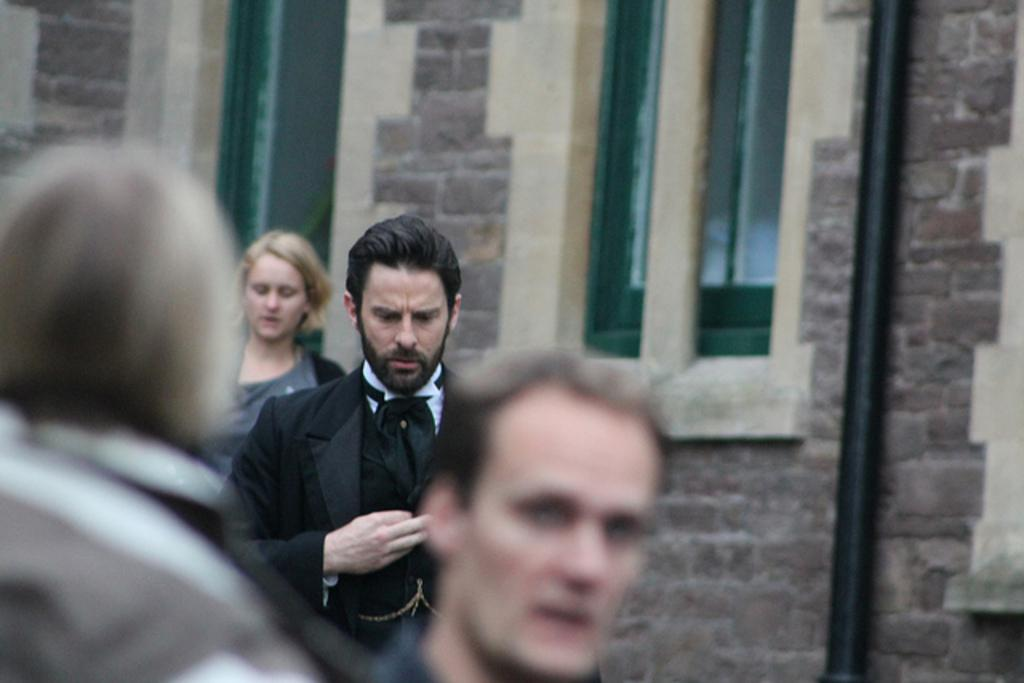What can be seen in the foreground of the image? There are people in the foreground of the image. What type of structure is on the right side of the image? There is a brick wall on the right side of the image. Can you describe the window in the image? There is a window between the wall in the image. What type of bed can be seen in the image? There is no bed present in the image. Can you provide an example of a similar image? The provided facts do not allow for a comparison to a similar image. 